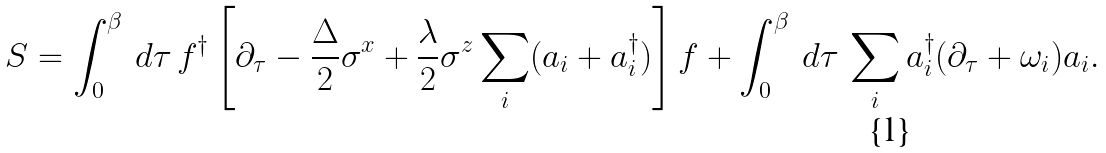Convert formula to latex. <formula><loc_0><loc_0><loc_500><loc_500>S = \int _ { 0 } ^ { \beta } \, d \tau \, f ^ { \dagger } \left [ \partial _ { \tau } - \frac { \Delta } { 2 } \sigma ^ { x } + \frac { \lambda } { 2 } \sigma ^ { z } \sum _ { i } ( a _ { i } + a _ { i } ^ { \dagger } ) \right ] f + \int _ { 0 } ^ { \beta } \, d \tau \, \sum _ { i } a _ { i } ^ { \dagger } ( \partial _ { \tau } + \omega _ { i } ) a _ { i } .</formula> 